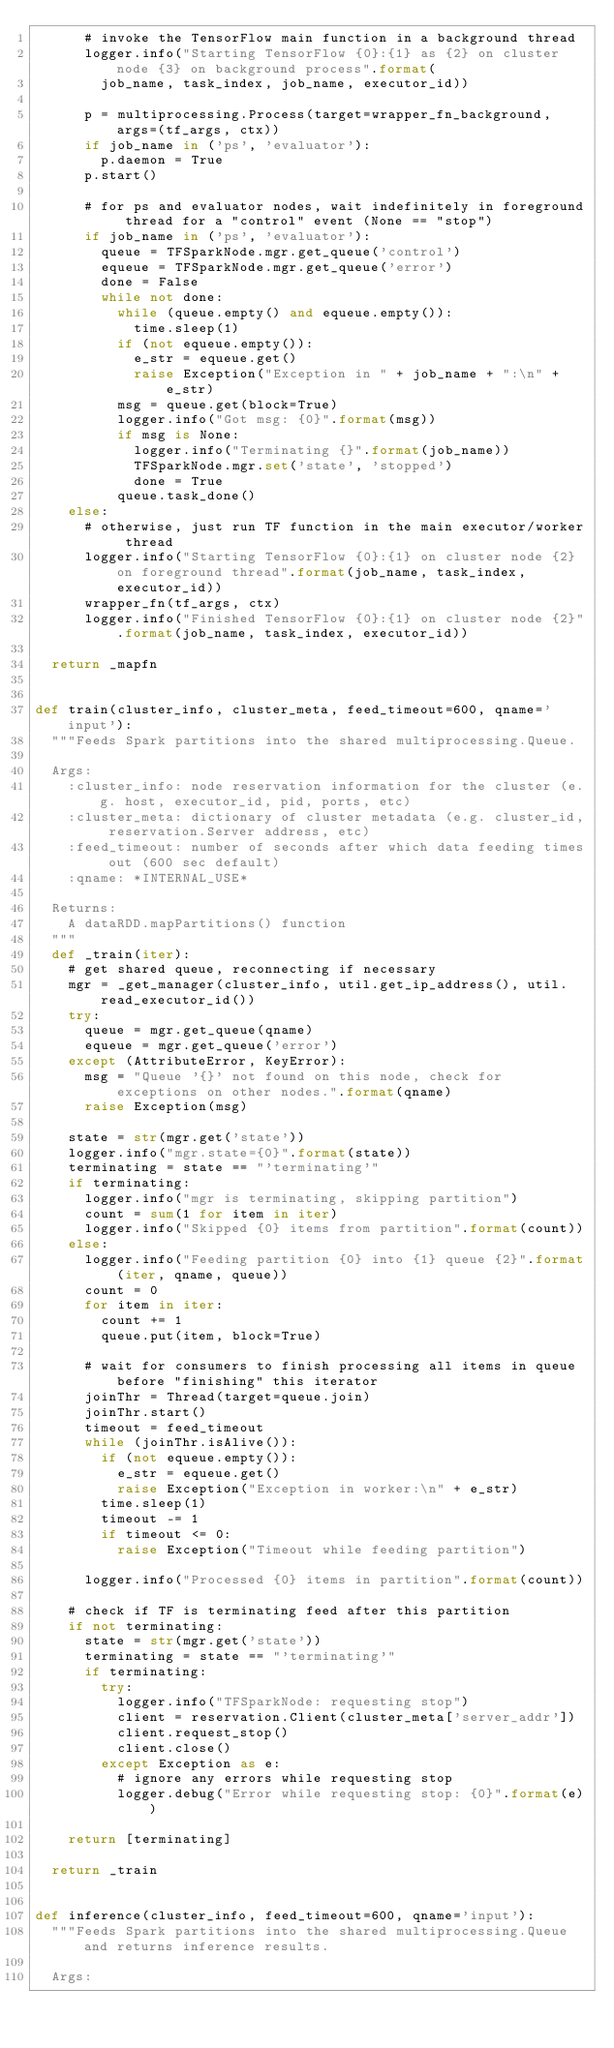Convert code to text. <code><loc_0><loc_0><loc_500><loc_500><_Python_>      # invoke the TensorFlow main function in a background thread
      logger.info("Starting TensorFlow {0}:{1} as {2} on cluster node {3} on background process".format(
        job_name, task_index, job_name, executor_id))

      p = multiprocessing.Process(target=wrapper_fn_background, args=(tf_args, ctx))
      if job_name in ('ps', 'evaluator'):
        p.daemon = True
      p.start()

      # for ps and evaluator nodes, wait indefinitely in foreground thread for a "control" event (None == "stop")
      if job_name in ('ps', 'evaluator'):
        queue = TFSparkNode.mgr.get_queue('control')
        equeue = TFSparkNode.mgr.get_queue('error')
        done = False
        while not done:
          while (queue.empty() and equeue.empty()):
            time.sleep(1)
          if (not equeue.empty()):
            e_str = equeue.get()
            raise Exception("Exception in " + job_name + ":\n" + e_str)
          msg = queue.get(block=True)
          logger.info("Got msg: {0}".format(msg))
          if msg is None:
            logger.info("Terminating {}".format(job_name))
            TFSparkNode.mgr.set('state', 'stopped')
            done = True
          queue.task_done()
    else:
      # otherwise, just run TF function in the main executor/worker thread
      logger.info("Starting TensorFlow {0}:{1} on cluster node {2} on foreground thread".format(job_name, task_index, executor_id))
      wrapper_fn(tf_args, ctx)
      logger.info("Finished TensorFlow {0}:{1} on cluster node {2}".format(job_name, task_index, executor_id))

  return _mapfn


def train(cluster_info, cluster_meta, feed_timeout=600, qname='input'):
  """Feeds Spark partitions into the shared multiprocessing.Queue.

  Args:
    :cluster_info: node reservation information for the cluster (e.g. host, executor_id, pid, ports, etc)
    :cluster_meta: dictionary of cluster metadata (e.g. cluster_id, reservation.Server address, etc)
    :feed_timeout: number of seconds after which data feeding times out (600 sec default)
    :qname: *INTERNAL_USE*

  Returns:
    A dataRDD.mapPartitions() function
  """
  def _train(iter):
    # get shared queue, reconnecting if necessary
    mgr = _get_manager(cluster_info, util.get_ip_address(), util.read_executor_id())
    try:
      queue = mgr.get_queue(qname)
      equeue = mgr.get_queue('error')
    except (AttributeError, KeyError):
      msg = "Queue '{}' not found on this node, check for exceptions on other nodes.".format(qname)
      raise Exception(msg)

    state = str(mgr.get('state'))
    logger.info("mgr.state={0}".format(state))
    terminating = state == "'terminating'"
    if terminating:
      logger.info("mgr is terminating, skipping partition")
      count = sum(1 for item in iter)
      logger.info("Skipped {0} items from partition".format(count))
    else:
      logger.info("Feeding partition {0} into {1} queue {2}".format(iter, qname, queue))
      count = 0
      for item in iter:
        count += 1
        queue.put(item, block=True)

      # wait for consumers to finish processing all items in queue before "finishing" this iterator
      joinThr = Thread(target=queue.join)
      joinThr.start()
      timeout = feed_timeout
      while (joinThr.isAlive()):
        if (not equeue.empty()):
          e_str = equeue.get()
          raise Exception("Exception in worker:\n" + e_str)
        time.sleep(1)
        timeout -= 1
        if timeout <= 0:
          raise Exception("Timeout while feeding partition")

      logger.info("Processed {0} items in partition".format(count))

    # check if TF is terminating feed after this partition
    if not terminating:
      state = str(mgr.get('state'))
      terminating = state == "'terminating'"
      if terminating:
        try:
          logger.info("TFSparkNode: requesting stop")
          client = reservation.Client(cluster_meta['server_addr'])
          client.request_stop()
          client.close()
        except Exception as e:
          # ignore any errors while requesting stop
          logger.debug("Error while requesting stop: {0}".format(e))

    return [terminating]

  return _train


def inference(cluster_info, feed_timeout=600, qname='input'):
  """Feeds Spark partitions into the shared multiprocessing.Queue and returns inference results.

  Args:</code> 